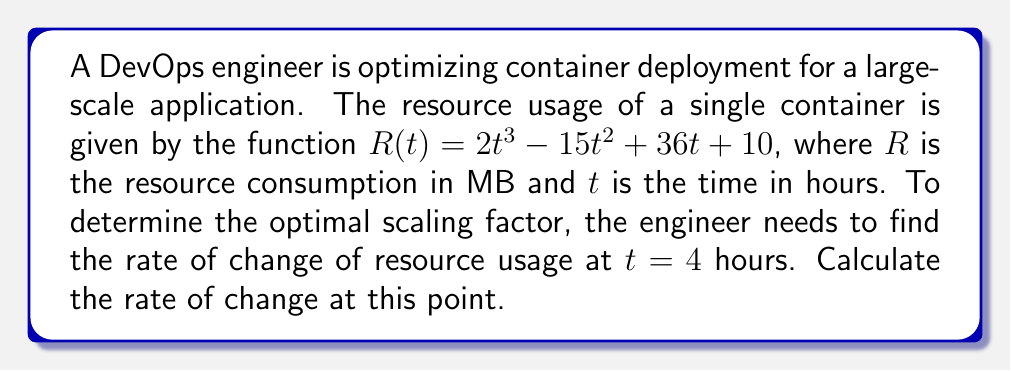What is the answer to this math problem? To find the rate of change of resource usage at $t = 4$ hours, we need to calculate the derivative of the function $R(t)$ and evaluate it at $t = 4$.

Step 1: Find the derivative of $R(t)$
$$R(t) = 2t^3 - 15t^2 + 36t + 10$$
$$R'(t) = 6t^2 - 30t + 36$$

Step 2: Evaluate $R'(t)$ at $t = 4$
$$R'(4) = 6(4)^2 - 30(4) + 36$$
$$R'(4) = 6(16) - 120 + 36$$
$$R'(4) = 96 - 120 + 36$$
$$R'(4) = 12$$

Therefore, the rate of change of resource usage at $t = 4$ hours is 12 MB per hour.
Answer: 12 MB/hour 